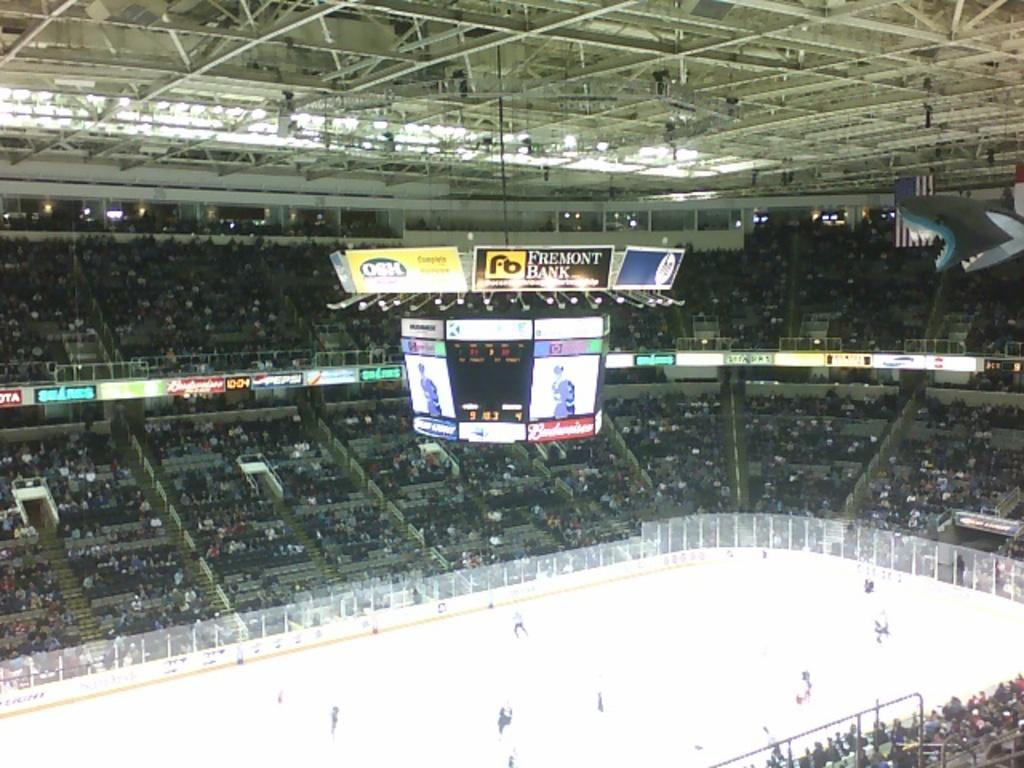<image>
Create a compact narrative representing the image presented. An ice hockey area that has an ad for Fremont Bank above its jumbo screen. 